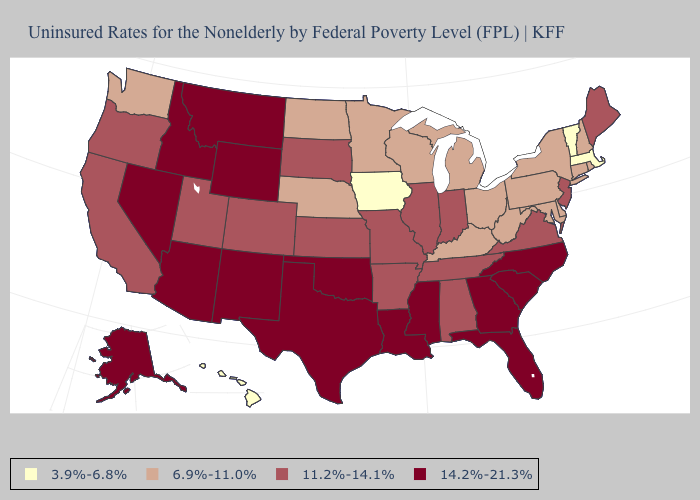Which states hav the highest value in the West?
Keep it brief. Alaska, Arizona, Idaho, Montana, Nevada, New Mexico, Wyoming. Does Hawaii have the lowest value in the West?
Quick response, please. Yes. What is the value of Michigan?
Be succinct. 6.9%-11.0%. What is the value of New Jersey?
Write a very short answer. 11.2%-14.1%. What is the value of Rhode Island?
Give a very brief answer. 6.9%-11.0%. Among the states that border Wyoming , which have the lowest value?
Be succinct. Nebraska. Which states have the lowest value in the USA?
Give a very brief answer. Hawaii, Iowa, Massachusetts, Vermont. What is the highest value in states that border West Virginia?
Be succinct. 11.2%-14.1%. What is the value of Kansas?
Write a very short answer. 11.2%-14.1%. What is the value of Virginia?
Be succinct. 11.2%-14.1%. Which states hav the highest value in the South?
Answer briefly. Florida, Georgia, Louisiana, Mississippi, North Carolina, Oklahoma, South Carolina, Texas. What is the value of Connecticut?
Answer briefly. 6.9%-11.0%. What is the highest value in the USA?
Quick response, please. 14.2%-21.3%. What is the value of Idaho?
Quick response, please. 14.2%-21.3%. 